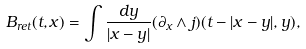<formula> <loc_0><loc_0><loc_500><loc_500>B _ { r e t } ( t , x ) = \int \frac { d y } { | x - y | } ( \partial _ { x } \wedge j ) ( t - | x - y | , y ) ,</formula> 